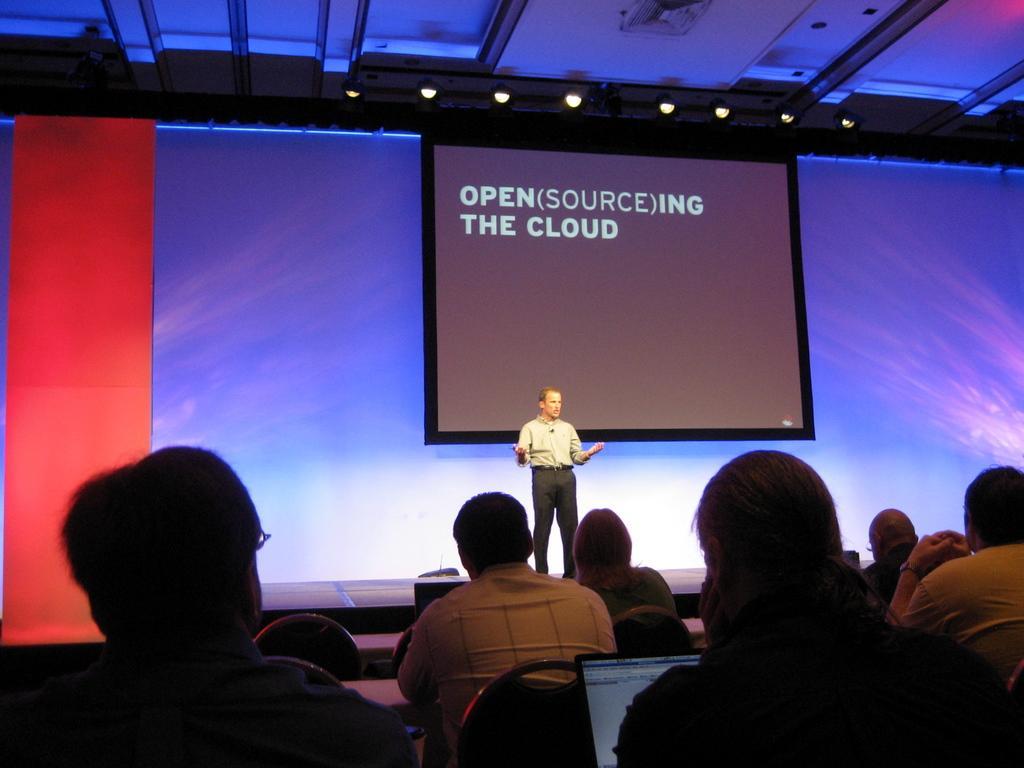How would you summarize this image in a sentence or two? In this image we can see some people sitting on chairs and there is a person standing on the stage and talking and we can see a screen with some text and there are some stage lights. 